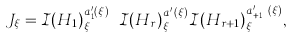Convert formula to latex. <formula><loc_0><loc_0><loc_500><loc_500>J _ { \xi } = \mathcal { I } ( H _ { 1 } ) ^ { a ^ { \prime } _ { 1 } ( \xi ) } _ { \xi } \cdots \mathcal { I } ( H _ { r } ) ^ { a ^ { \prime } _ { r } ( \xi ) } _ { \xi } \mathcal { I } ( H _ { r + 1 } ) ^ { a ^ { \prime } _ { r + 1 } ( \xi ) } _ { \xi } ,</formula> 